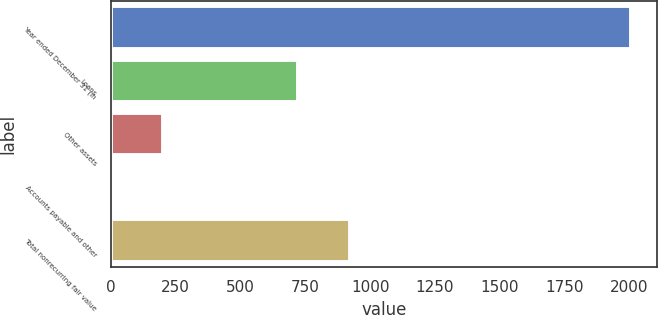Convert chart to OTSL. <chart><loc_0><loc_0><loc_500><loc_500><bar_chart><fcel>Year ended December 31 (in<fcel>Loans<fcel>Other assets<fcel>Accounts payable and other<fcel>Total nonrecurring fair value<nl><fcel>2007<fcel>720<fcel>202.5<fcel>2<fcel>920.5<nl></chart> 